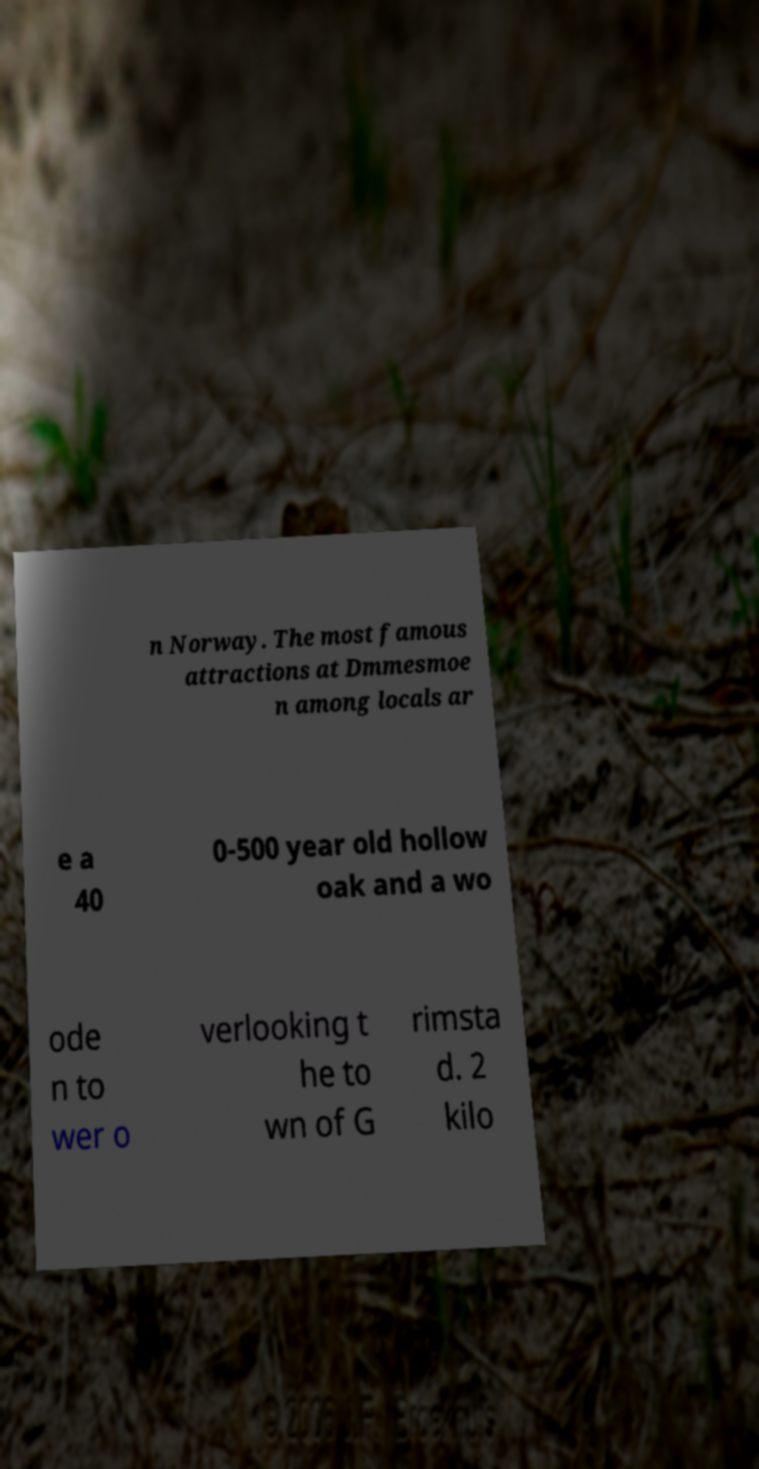Please identify and transcribe the text found in this image. n Norway. The most famous attractions at Dmmesmoe n among locals ar e a 40 0-500 year old hollow oak and a wo ode n to wer o verlooking t he to wn of G rimsta d. 2 kilo 